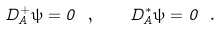Convert formula to latex. <formula><loc_0><loc_0><loc_500><loc_500>D _ { A } ^ { + } { \psi } = 0 \ , \quad D _ { A } ^ { * } { \psi } = 0 \ .</formula> 